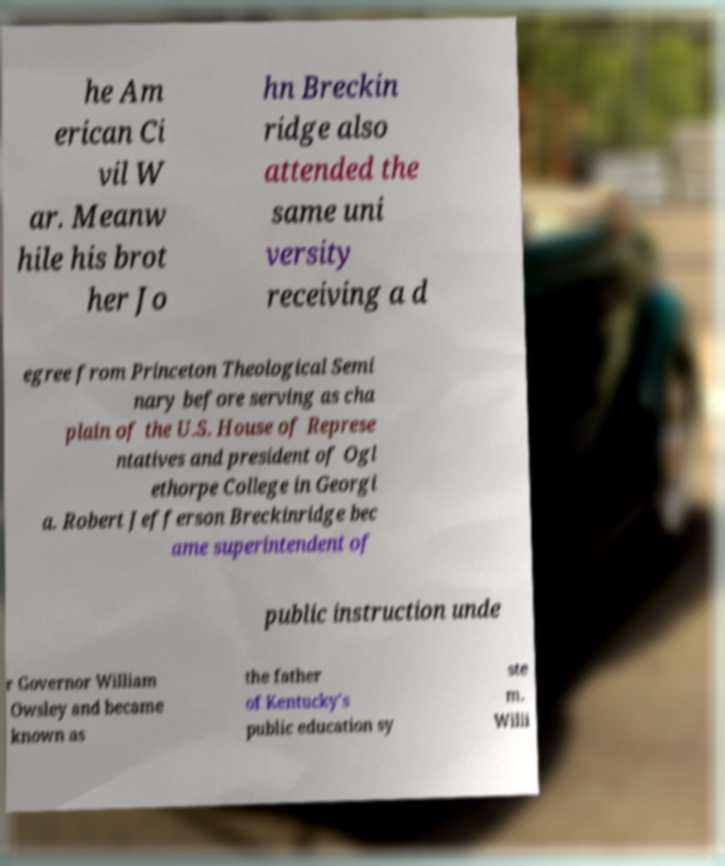Please identify and transcribe the text found in this image. he Am erican Ci vil W ar. Meanw hile his brot her Jo hn Breckin ridge also attended the same uni versity receiving a d egree from Princeton Theological Semi nary before serving as cha plain of the U.S. House of Represe ntatives and president of Ogl ethorpe College in Georgi a. Robert Jefferson Breckinridge bec ame superintendent of public instruction unde r Governor William Owsley and became known as the father of Kentucky's public education sy ste m. Willi 